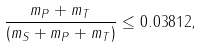<formula> <loc_0><loc_0><loc_500><loc_500>\frac { m _ { P } + m _ { T } } { ( m _ { S } + m _ { P } + m _ { T } ) } \leq 0 . 0 3 8 1 2 ,</formula> 